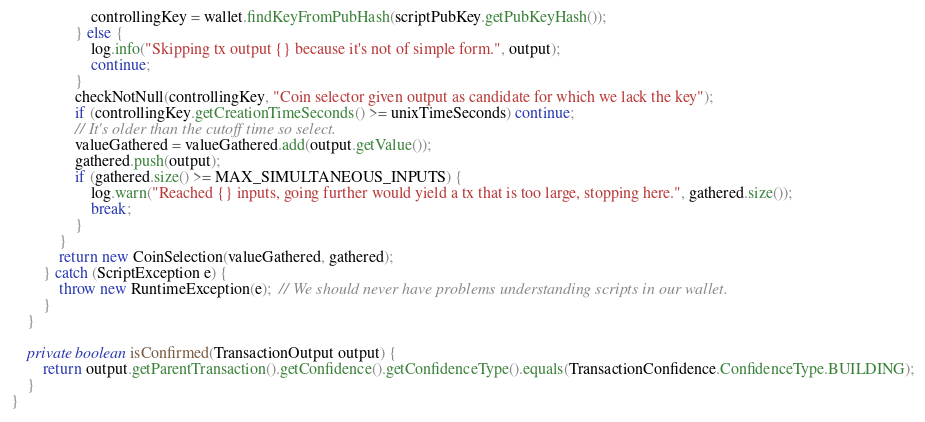<code> <loc_0><loc_0><loc_500><loc_500><_Java_>                    controllingKey = wallet.findKeyFromPubHash(scriptPubKey.getPubKeyHash());
                } else {
                    log.info("Skipping tx output {} because it's not of simple form.", output);
                    continue;
                }
                checkNotNull(controllingKey, "Coin selector given output as candidate for which we lack the key");
                if (controllingKey.getCreationTimeSeconds() >= unixTimeSeconds) continue;
                // It's older than the cutoff time so select.
                valueGathered = valueGathered.add(output.getValue());
                gathered.push(output);
                if (gathered.size() >= MAX_SIMULTANEOUS_INPUTS) {
                    log.warn("Reached {} inputs, going further would yield a tx that is too large, stopping here.", gathered.size());
                    break;
                }
            }
            return new CoinSelection(valueGathered, gathered);
        } catch (ScriptException e) {
            throw new RuntimeException(e);  // We should never have problems understanding scripts in our wallet.
        }
    }

    private boolean isConfirmed(TransactionOutput output) {
        return output.getParentTransaction().getConfidence().getConfidenceType().equals(TransactionConfidence.ConfidenceType.BUILDING);
    }
}
</code> 